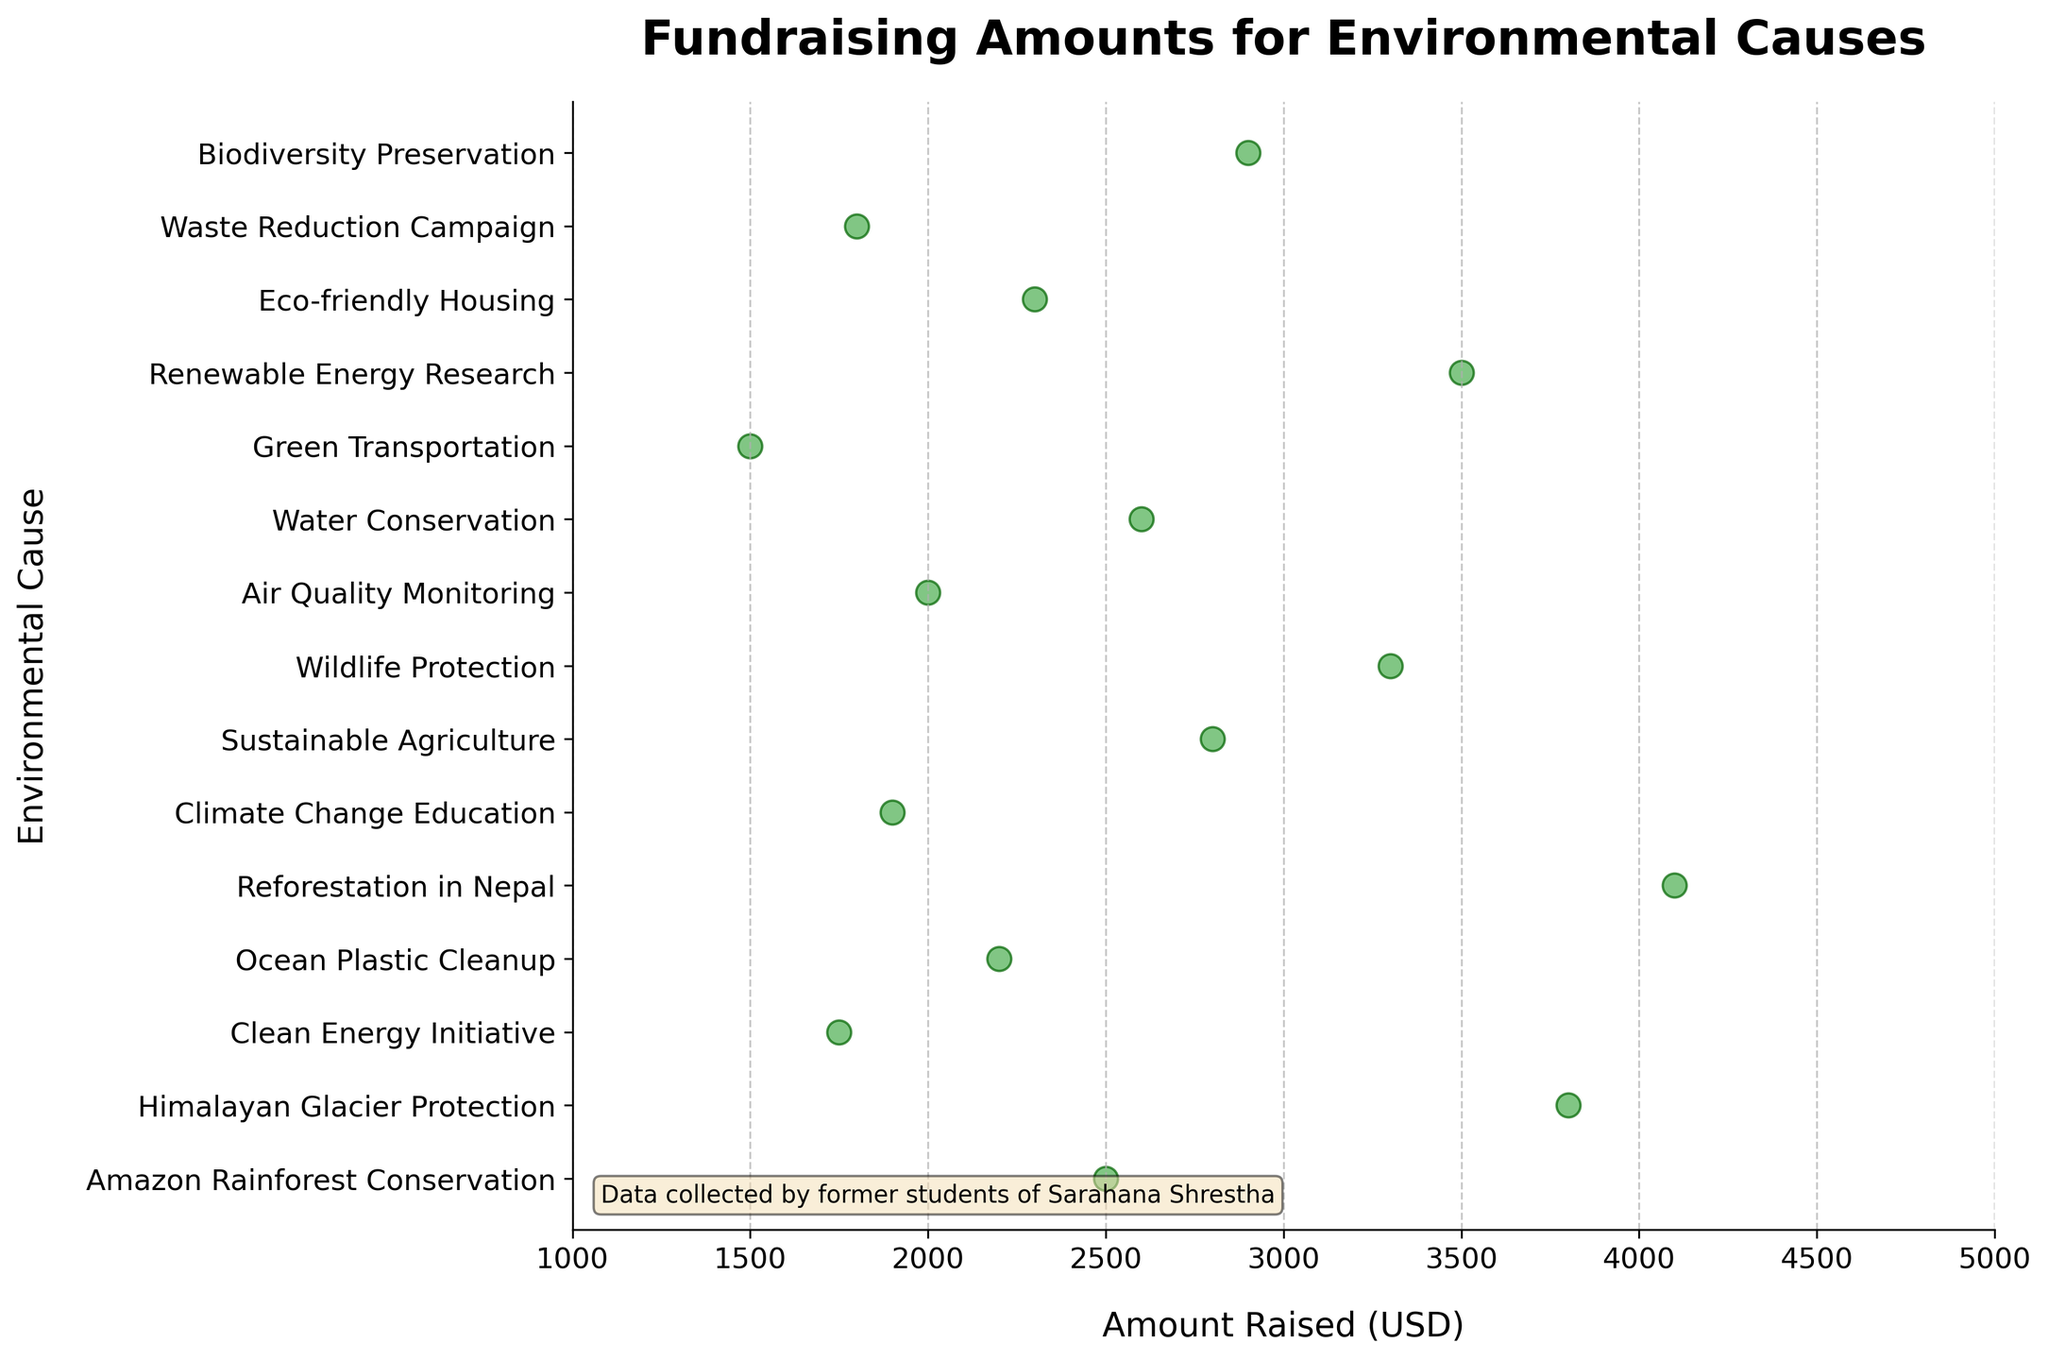What is the title of the figure? The title is the text displayed at the top of the figure, which provides an overview of what the data represents. In this plot, it is clearly indicated.
Answer: Fundraising Amounts for Environmental Causes What is the range of the x-axis? The x-axis represents the Amount Raised (USD). Observing the figure, we see that it starts at 1000 and ends at 5000.
Answer: 1000 to 5000 Which environmental cause raised the highest amount? To answer this, observe the highest point on the x-axis and find the corresponding cause on the y-axis. The highest amount is 4100 for Reforestation in Nepal.
Answer: Reforestation in Nepal Which cause raised the smallest amount of money? Inspect the lowest point on the x-axis to find the corresponding cause. The smallest amount is 1500 for Green Transportation.
Answer: Green Transportation How many environmental causes raised over $3000? Count the number of points beyond the $3000 mark on the x-axis. In the figure, three causes (Himalayan Glacier Protection, Reforestation in Nepal, and Renewable Energy Research) raised over $3000.
Answer: 3 What is the average amount raised for all causes? Sum all the amounts and divide by the number of causes: (2500 + 3800 + 1750 + 2200 + 4100 + 1900 + 2800 + 3300 + 2000 + 2600 + 1500 + 3500 + 2300 + 1800 + 2900) / 15 = 2810 USD.
Answer: 2810 USD Which causes raised amounts between $2000 and $3000? Locate the points on the x-axis between $2000 and $3000 and identify their corresponding causes. They are Water Conservation, Amazon Rainforest Conservation, Sustainable Agriculture, Eco-friendly Housing, and Biodiversity Preservation.
Answer: Water Conservation, Amazon Rainforest Conservation, Sustainable Agriculture, Eco-friendly Housing, Biodiversity Preservation Is there a cause that raised exactly $2200? By observing the figure, we notice that there is indeed a cause at $2200, which is the Ocean Plastic Cleanup.
Answer: Ocean Plastic Cleanup What is the median amount raised across all causes? To find the median, list all the amounts in ascending order: 1500, 1750, 1800, 1900, 2000, 2200, 2300, 2500, 2600, 2800, 2900, 3300, 3500, 3800, 4100. The middle value (8th in the list) is 2500.
Answer: 2500 USD Which cause raised $100 more than the amount raised for Waste Reduction Campaign? Locate the amount raised by Waste Reduction Campaign ($1800) and add $100 to get $1900. The cause that raised $1900 is Climate Change Education.
Answer: Climate Change Education 